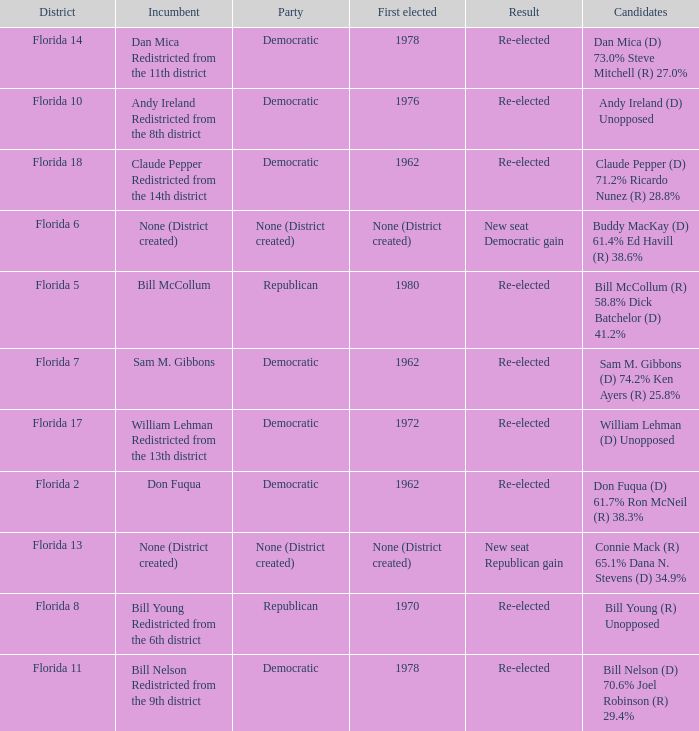 how many candidates with result being new seat democratic gain 1.0. Help me parse the entirety of this table. {'header': ['District', 'Incumbent', 'Party', 'First elected', 'Result', 'Candidates'], 'rows': [['Florida 14', 'Dan Mica Redistricted from the 11th district', 'Democratic', '1978', 'Re-elected', 'Dan Mica (D) 73.0% Steve Mitchell (R) 27.0%'], ['Florida 10', 'Andy Ireland Redistricted from the 8th district', 'Democratic', '1976', 'Re-elected', 'Andy Ireland (D) Unopposed'], ['Florida 18', 'Claude Pepper Redistricted from the 14th district', 'Democratic', '1962', 'Re-elected', 'Claude Pepper (D) 71.2% Ricardo Nunez (R) 28.8%'], ['Florida 6', 'None (District created)', 'None (District created)', 'None (District created)', 'New seat Democratic gain', 'Buddy MacKay (D) 61.4% Ed Havill (R) 38.6%'], ['Florida 5', 'Bill McCollum', 'Republican', '1980', 'Re-elected', 'Bill McCollum (R) 58.8% Dick Batchelor (D) 41.2%'], ['Florida 7', 'Sam M. Gibbons', 'Democratic', '1962', 'Re-elected', 'Sam M. Gibbons (D) 74.2% Ken Ayers (R) 25.8%'], ['Florida 17', 'William Lehman Redistricted from the 13th district', 'Democratic', '1972', 'Re-elected', 'William Lehman (D) Unopposed'], ['Florida 2', 'Don Fuqua', 'Democratic', '1962', 'Re-elected', 'Don Fuqua (D) 61.7% Ron McNeil (R) 38.3%'], ['Florida 13', 'None (District created)', 'None (District created)', 'None (District created)', 'New seat Republican gain', 'Connie Mack (R) 65.1% Dana N. Stevens (D) 34.9%'], ['Florida 8', 'Bill Young Redistricted from the 6th district', 'Republican', '1970', 'Re-elected', 'Bill Young (R) Unopposed'], ['Florida 11', 'Bill Nelson Redistricted from the 9th district', 'Democratic', '1978', 'Re-elected', 'Bill Nelson (D) 70.6% Joel Robinson (R) 29.4%']]} 